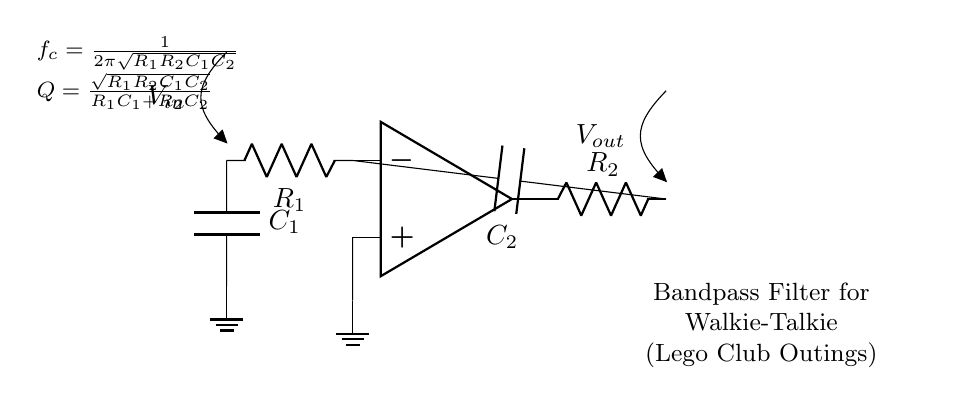What components are used in this bandpass filter? The circuit diagram shows two resistors (R1 and R2) and two capacitors (C1 and C2) along with an operational amplifier.
Answer: Resistor and capacitor What is the function of the operational amplifier in this circuit? The operational amplifier amplifies the difference in voltage between its inverting and non-inverting inputs, allowing the filter to selectively pass frequencies.
Answer: Amplification What is the cut-off frequency of this bandpass filter? The formula for the cut-off frequency is given as f_c = 1/(2π√(R1R2C1C2)), which incorporates the resistances and capacitances in the circuit.
Answer: 1/(2π√(R1R2C1C2)) How does the quality factor (Q) relate to this bandpass filter? The quality factor, Q, is calculated using the formula Q = √(R1R2C1C2)/(R1C1 + R2C2), indicating the selectivity and bandwidth of the filter.
Answer: √(R1R2C1C2)/(R1C1 + R2C2) What happens to the output when the input frequency is outside the passband? When the input frequency is outside the passband, the output voltage will drop significantly, as those frequencies are attenuated by the filter.
Answer: Output voltage drops 